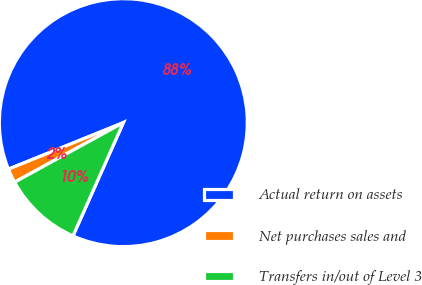Convert chart. <chart><loc_0><loc_0><loc_500><loc_500><pie_chart><fcel>Actual return on assets<fcel>Net purchases sales and<fcel>Transfers in/out of Level 3<nl><fcel>87.78%<fcel>1.85%<fcel>10.37%<nl></chart> 